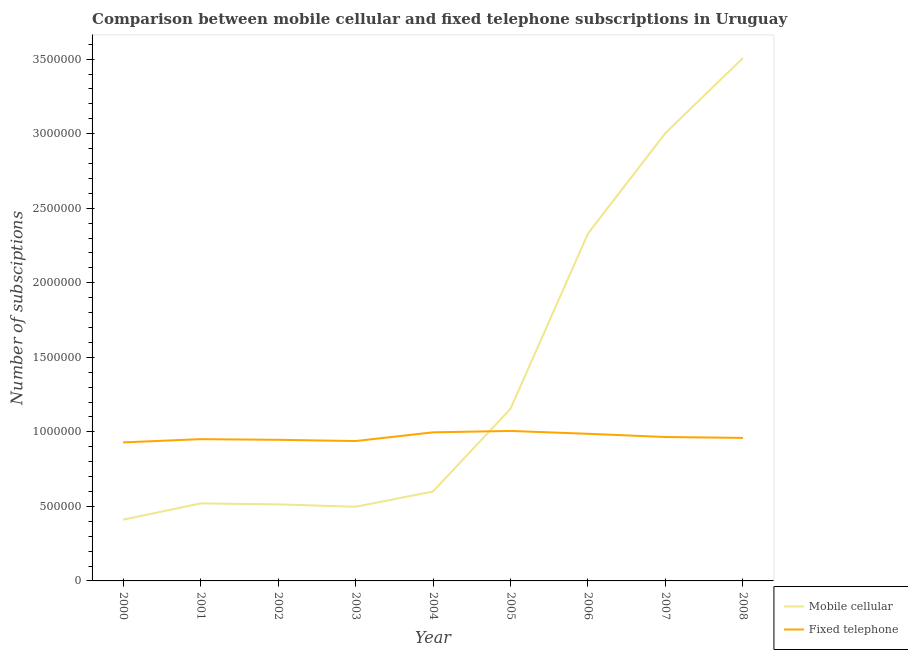What is the number of mobile cellular subscriptions in 2003?
Your answer should be compact. 4.98e+05. Across all years, what is the maximum number of mobile cellular subscriptions?
Offer a very short reply. 3.51e+06. Across all years, what is the minimum number of mobile cellular subscriptions?
Your answer should be very brief. 4.11e+05. In which year was the number of fixed telephone subscriptions minimum?
Your answer should be very brief. 2000. What is the total number of mobile cellular subscriptions in the graph?
Give a very brief answer. 1.25e+07. What is the difference between the number of mobile cellular subscriptions in 2004 and that in 2007?
Your response must be concise. -2.40e+06. What is the difference between the number of fixed telephone subscriptions in 2007 and the number of mobile cellular subscriptions in 2006?
Provide a short and direct response. -1.36e+06. What is the average number of mobile cellular subscriptions per year?
Give a very brief answer. 1.39e+06. In the year 2000, what is the difference between the number of fixed telephone subscriptions and number of mobile cellular subscriptions?
Your answer should be compact. 5.18e+05. What is the ratio of the number of fixed telephone subscriptions in 2005 to that in 2007?
Make the answer very short. 1.04. Is the number of fixed telephone subscriptions in 2000 less than that in 2006?
Ensure brevity in your answer.  Yes. Is the difference between the number of mobile cellular subscriptions in 2003 and 2008 greater than the difference between the number of fixed telephone subscriptions in 2003 and 2008?
Offer a very short reply. No. What is the difference between the highest and the second highest number of fixed telephone subscriptions?
Ensure brevity in your answer.  9300. What is the difference between the highest and the lowest number of mobile cellular subscriptions?
Your answer should be compact. 3.10e+06. Is the sum of the number of fixed telephone subscriptions in 2001 and 2008 greater than the maximum number of mobile cellular subscriptions across all years?
Make the answer very short. No. Is the number of mobile cellular subscriptions strictly greater than the number of fixed telephone subscriptions over the years?
Offer a terse response. No. Does the graph contain any zero values?
Keep it short and to the point. No. Where does the legend appear in the graph?
Your answer should be very brief. Bottom right. How many legend labels are there?
Your answer should be very brief. 2. How are the legend labels stacked?
Give a very brief answer. Vertical. What is the title of the graph?
Offer a terse response. Comparison between mobile cellular and fixed telephone subscriptions in Uruguay. What is the label or title of the X-axis?
Make the answer very short. Year. What is the label or title of the Y-axis?
Keep it short and to the point. Number of subsciptions. What is the Number of subsciptions in Mobile cellular in 2000?
Offer a terse response. 4.11e+05. What is the Number of subsciptions in Fixed telephone in 2000?
Your answer should be very brief. 9.29e+05. What is the Number of subsciptions of Mobile cellular in 2001?
Provide a short and direct response. 5.20e+05. What is the Number of subsciptions of Fixed telephone in 2001?
Your response must be concise. 9.51e+05. What is the Number of subsciptions in Mobile cellular in 2002?
Give a very brief answer. 5.14e+05. What is the Number of subsciptions in Fixed telephone in 2002?
Give a very brief answer. 9.47e+05. What is the Number of subsciptions of Mobile cellular in 2003?
Give a very brief answer. 4.98e+05. What is the Number of subsciptions of Fixed telephone in 2003?
Offer a very short reply. 9.38e+05. What is the Number of subsciptions of Mobile cellular in 2004?
Your response must be concise. 6.00e+05. What is the Number of subsciptions of Fixed telephone in 2004?
Make the answer very short. 9.97e+05. What is the Number of subsciptions in Mobile cellular in 2005?
Provide a succinct answer. 1.15e+06. What is the Number of subsciptions in Fixed telephone in 2005?
Your answer should be very brief. 1.01e+06. What is the Number of subsciptions of Mobile cellular in 2006?
Keep it short and to the point. 2.33e+06. What is the Number of subsciptions in Fixed telephone in 2006?
Offer a terse response. 9.87e+05. What is the Number of subsciptions of Mobile cellular in 2007?
Ensure brevity in your answer.  3.00e+06. What is the Number of subsciptions of Fixed telephone in 2007?
Provide a succinct answer. 9.65e+05. What is the Number of subsciptions in Mobile cellular in 2008?
Ensure brevity in your answer.  3.51e+06. What is the Number of subsciptions in Fixed telephone in 2008?
Make the answer very short. 9.59e+05. Across all years, what is the maximum Number of subsciptions of Mobile cellular?
Keep it short and to the point. 3.51e+06. Across all years, what is the maximum Number of subsciptions in Fixed telephone?
Your answer should be compact. 1.01e+06. Across all years, what is the minimum Number of subsciptions of Mobile cellular?
Keep it short and to the point. 4.11e+05. Across all years, what is the minimum Number of subsciptions of Fixed telephone?
Provide a succinct answer. 9.29e+05. What is the total Number of subsciptions of Mobile cellular in the graph?
Make the answer very short. 1.25e+07. What is the total Number of subsciptions in Fixed telephone in the graph?
Provide a succinct answer. 8.68e+06. What is the difference between the Number of subsciptions of Mobile cellular in 2000 and that in 2001?
Make the answer very short. -1.09e+05. What is the difference between the Number of subsciptions of Fixed telephone in 2000 and that in 2001?
Ensure brevity in your answer.  -2.17e+04. What is the difference between the Number of subsciptions of Mobile cellular in 2000 and that in 2002?
Provide a succinct answer. -1.03e+05. What is the difference between the Number of subsciptions of Fixed telephone in 2000 and that in 2002?
Provide a short and direct response. -1.74e+04. What is the difference between the Number of subsciptions of Mobile cellular in 2000 and that in 2003?
Offer a terse response. -8.67e+04. What is the difference between the Number of subsciptions of Fixed telephone in 2000 and that in 2003?
Your response must be concise. -9045. What is the difference between the Number of subsciptions of Mobile cellular in 2000 and that in 2004?
Ensure brevity in your answer.  -1.89e+05. What is the difference between the Number of subsciptions of Fixed telephone in 2000 and that in 2004?
Provide a short and direct response. -6.76e+04. What is the difference between the Number of subsciptions in Mobile cellular in 2000 and that in 2005?
Make the answer very short. -7.44e+05. What is the difference between the Number of subsciptions of Fixed telephone in 2000 and that in 2005?
Give a very brief answer. -7.69e+04. What is the difference between the Number of subsciptions of Mobile cellular in 2000 and that in 2006?
Ensure brevity in your answer.  -1.92e+06. What is the difference between the Number of subsciptions of Fixed telephone in 2000 and that in 2006?
Your response must be concise. -5.77e+04. What is the difference between the Number of subsciptions in Mobile cellular in 2000 and that in 2007?
Provide a succinct answer. -2.59e+06. What is the difference between the Number of subsciptions in Fixed telephone in 2000 and that in 2007?
Offer a very short reply. -3.61e+04. What is the difference between the Number of subsciptions in Mobile cellular in 2000 and that in 2008?
Make the answer very short. -3.10e+06. What is the difference between the Number of subsciptions of Fixed telephone in 2000 and that in 2008?
Give a very brief answer. -3.01e+04. What is the difference between the Number of subsciptions of Mobile cellular in 2001 and that in 2002?
Provide a succinct answer. 6463. What is the difference between the Number of subsciptions of Fixed telephone in 2001 and that in 2002?
Give a very brief answer. 4333. What is the difference between the Number of subsciptions of Mobile cellular in 2001 and that in 2003?
Provide a short and direct response. 2.25e+04. What is the difference between the Number of subsciptions in Fixed telephone in 2001 and that in 2003?
Your answer should be compact. 1.27e+04. What is the difference between the Number of subsciptions of Mobile cellular in 2001 and that in 2004?
Ensure brevity in your answer.  -7.98e+04. What is the difference between the Number of subsciptions of Fixed telephone in 2001 and that in 2004?
Give a very brief answer. -4.58e+04. What is the difference between the Number of subsciptions in Mobile cellular in 2001 and that in 2005?
Provide a succinct answer. -6.35e+05. What is the difference between the Number of subsciptions in Fixed telephone in 2001 and that in 2005?
Offer a very short reply. -5.51e+04. What is the difference between the Number of subsciptions in Mobile cellular in 2001 and that in 2006?
Your answer should be compact. -1.81e+06. What is the difference between the Number of subsciptions in Fixed telephone in 2001 and that in 2006?
Your response must be concise. -3.60e+04. What is the difference between the Number of subsciptions in Mobile cellular in 2001 and that in 2007?
Keep it short and to the point. -2.48e+06. What is the difference between the Number of subsciptions of Fixed telephone in 2001 and that in 2007?
Keep it short and to the point. -1.44e+04. What is the difference between the Number of subsciptions in Mobile cellular in 2001 and that in 2008?
Give a very brief answer. -2.99e+06. What is the difference between the Number of subsciptions of Fixed telephone in 2001 and that in 2008?
Give a very brief answer. -8420. What is the difference between the Number of subsciptions in Mobile cellular in 2002 and that in 2003?
Make the answer very short. 1.60e+04. What is the difference between the Number of subsciptions in Fixed telephone in 2002 and that in 2003?
Offer a very short reply. 8347. What is the difference between the Number of subsciptions in Mobile cellular in 2002 and that in 2004?
Keep it short and to the point. -8.62e+04. What is the difference between the Number of subsciptions in Fixed telephone in 2002 and that in 2004?
Give a very brief answer. -5.02e+04. What is the difference between the Number of subsciptions in Mobile cellular in 2002 and that in 2005?
Offer a very short reply. -6.41e+05. What is the difference between the Number of subsciptions in Fixed telephone in 2002 and that in 2005?
Offer a very short reply. -5.95e+04. What is the difference between the Number of subsciptions in Mobile cellular in 2002 and that in 2006?
Keep it short and to the point. -1.82e+06. What is the difference between the Number of subsciptions of Fixed telephone in 2002 and that in 2006?
Provide a short and direct response. -4.03e+04. What is the difference between the Number of subsciptions of Mobile cellular in 2002 and that in 2007?
Your answer should be compact. -2.49e+06. What is the difference between the Number of subsciptions in Fixed telephone in 2002 and that in 2007?
Your answer should be compact. -1.87e+04. What is the difference between the Number of subsciptions of Mobile cellular in 2002 and that in 2008?
Offer a terse response. -2.99e+06. What is the difference between the Number of subsciptions of Fixed telephone in 2002 and that in 2008?
Your answer should be compact. -1.28e+04. What is the difference between the Number of subsciptions of Mobile cellular in 2003 and that in 2004?
Your response must be concise. -1.02e+05. What is the difference between the Number of subsciptions in Fixed telephone in 2003 and that in 2004?
Offer a terse response. -5.85e+04. What is the difference between the Number of subsciptions of Mobile cellular in 2003 and that in 2005?
Offer a very short reply. -6.57e+05. What is the difference between the Number of subsciptions in Fixed telephone in 2003 and that in 2005?
Keep it short and to the point. -6.78e+04. What is the difference between the Number of subsciptions in Mobile cellular in 2003 and that in 2006?
Your answer should be very brief. -1.83e+06. What is the difference between the Number of subsciptions of Fixed telephone in 2003 and that in 2006?
Give a very brief answer. -4.87e+04. What is the difference between the Number of subsciptions of Mobile cellular in 2003 and that in 2007?
Ensure brevity in your answer.  -2.51e+06. What is the difference between the Number of subsciptions of Fixed telephone in 2003 and that in 2007?
Provide a short and direct response. -2.70e+04. What is the difference between the Number of subsciptions in Mobile cellular in 2003 and that in 2008?
Your answer should be compact. -3.01e+06. What is the difference between the Number of subsciptions of Fixed telephone in 2003 and that in 2008?
Make the answer very short. -2.11e+04. What is the difference between the Number of subsciptions in Mobile cellular in 2004 and that in 2005?
Your answer should be very brief. -5.55e+05. What is the difference between the Number of subsciptions in Fixed telephone in 2004 and that in 2005?
Give a very brief answer. -9300. What is the difference between the Number of subsciptions in Mobile cellular in 2004 and that in 2006?
Offer a very short reply. -1.73e+06. What is the difference between the Number of subsciptions of Fixed telephone in 2004 and that in 2006?
Keep it short and to the point. 9834. What is the difference between the Number of subsciptions of Mobile cellular in 2004 and that in 2007?
Ensure brevity in your answer.  -2.40e+06. What is the difference between the Number of subsciptions of Fixed telephone in 2004 and that in 2007?
Provide a short and direct response. 3.15e+04. What is the difference between the Number of subsciptions of Mobile cellular in 2004 and that in 2008?
Provide a succinct answer. -2.91e+06. What is the difference between the Number of subsciptions of Fixed telephone in 2004 and that in 2008?
Provide a short and direct response. 3.74e+04. What is the difference between the Number of subsciptions of Mobile cellular in 2005 and that in 2006?
Offer a very short reply. -1.18e+06. What is the difference between the Number of subsciptions of Fixed telephone in 2005 and that in 2006?
Your answer should be very brief. 1.91e+04. What is the difference between the Number of subsciptions in Mobile cellular in 2005 and that in 2007?
Make the answer very short. -1.85e+06. What is the difference between the Number of subsciptions in Fixed telephone in 2005 and that in 2007?
Make the answer very short. 4.08e+04. What is the difference between the Number of subsciptions in Mobile cellular in 2005 and that in 2008?
Keep it short and to the point. -2.35e+06. What is the difference between the Number of subsciptions of Fixed telephone in 2005 and that in 2008?
Provide a succinct answer. 4.67e+04. What is the difference between the Number of subsciptions of Mobile cellular in 2006 and that in 2007?
Give a very brief answer. -6.74e+05. What is the difference between the Number of subsciptions of Fixed telephone in 2006 and that in 2007?
Give a very brief answer. 2.17e+04. What is the difference between the Number of subsciptions of Mobile cellular in 2006 and that in 2008?
Provide a short and direct response. -1.18e+06. What is the difference between the Number of subsciptions in Fixed telephone in 2006 and that in 2008?
Keep it short and to the point. 2.76e+04. What is the difference between the Number of subsciptions in Mobile cellular in 2007 and that in 2008?
Your answer should be very brief. -5.03e+05. What is the difference between the Number of subsciptions in Fixed telephone in 2007 and that in 2008?
Offer a very short reply. 5930. What is the difference between the Number of subsciptions in Mobile cellular in 2000 and the Number of subsciptions in Fixed telephone in 2001?
Offer a terse response. -5.40e+05. What is the difference between the Number of subsciptions in Mobile cellular in 2000 and the Number of subsciptions in Fixed telephone in 2002?
Provide a succinct answer. -5.36e+05. What is the difference between the Number of subsciptions in Mobile cellular in 2000 and the Number of subsciptions in Fixed telephone in 2003?
Provide a short and direct response. -5.27e+05. What is the difference between the Number of subsciptions in Mobile cellular in 2000 and the Number of subsciptions in Fixed telephone in 2004?
Your response must be concise. -5.86e+05. What is the difference between the Number of subsciptions of Mobile cellular in 2000 and the Number of subsciptions of Fixed telephone in 2005?
Ensure brevity in your answer.  -5.95e+05. What is the difference between the Number of subsciptions of Mobile cellular in 2000 and the Number of subsciptions of Fixed telephone in 2006?
Keep it short and to the point. -5.76e+05. What is the difference between the Number of subsciptions in Mobile cellular in 2000 and the Number of subsciptions in Fixed telephone in 2007?
Offer a terse response. -5.54e+05. What is the difference between the Number of subsciptions of Mobile cellular in 2000 and the Number of subsciptions of Fixed telephone in 2008?
Ensure brevity in your answer.  -5.48e+05. What is the difference between the Number of subsciptions in Mobile cellular in 2001 and the Number of subsciptions in Fixed telephone in 2002?
Offer a very short reply. -4.27e+05. What is the difference between the Number of subsciptions of Mobile cellular in 2001 and the Number of subsciptions of Fixed telephone in 2003?
Offer a very short reply. -4.18e+05. What is the difference between the Number of subsciptions in Mobile cellular in 2001 and the Number of subsciptions in Fixed telephone in 2004?
Your response must be concise. -4.77e+05. What is the difference between the Number of subsciptions of Mobile cellular in 2001 and the Number of subsciptions of Fixed telephone in 2005?
Your answer should be very brief. -4.86e+05. What is the difference between the Number of subsciptions in Mobile cellular in 2001 and the Number of subsciptions in Fixed telephone in 2006?
Make the answer very short. -4.67e+05. What is the difference between the Number of subsciptions in Mobile cellular in 2001 and the Number of subsciptions in Fixed telephone in 2007?
Your response must be concise. -4.45e+05. What is the difference between the Number of subsciptions of Mobile cellular in 2001 and the Number of subsciptions of Fixed telephone in 2008?
Keep it short and to the point. -4.39e+05. What is the difference between the Number of subsciptions in Mobile cellular in 2002 and the Number of subsciptions in Fixed telephone in 2003?
Provide a short and direct response. -4.25e+05. What is the difference between the Number of subsciptions in Mobile cellular in 2002 and the Number of subsciptions in Fixed telephone in 2004?
Your answer should be compact. -4.83e+05. What is the difference between the Number of subsciptions in Mobile cellular in 2002 and the Number of subsciptions in Fixed telephone in 2005?
Give a very brief answer. -4.92e+05. What is the difference between the Number of subsciptions in Mobile cellular in 2002 and the Number of subsciptions in Fixed telephone in 2006?
Keep it short and to the point. -4.73e+05. What is the difference between the Number of subsciptions of Mobile cellular in 2002 and the Number of subsciptions of Fixed telephone in 2007?
Your response must be concise. -4.52e+05. What is the difference between the Number of subsciptions in Mobile cellular in 2002 and the Number of subsciptions in Fixed telephone in 2008?
Provide a succinct answer. -4.46e+05. What is the difference between the Number of subsciptions in Mobile cellular in 2003 and the Number of subsciptions in Fixed telephone in 2004?
Make the answer very short. -4.99e+05. What is the difference between the Number of subsciptions in Mobile cellular in 2003 and the Number of subsciptions in Fixed telephone in 2005?
Offer a terse response. -5.08e+05. What is the difference between the Number of subsciptions in Mobile cellular in 2003 and the Number of subsciptions in Fixed telephone in 2006?
Offer a very short reply. -4.89e+05. What is the difference between the Number of subsciptions in Mobile cellular in 2003 and the Number of subsciptions in Fixed telephone in 2007?
Provide a succinct answer. -4.68e+05. What is the difference between the Number of subsciptions in Mobile cellular in 2003 and the Number of subsciptions in Fixed telephone in 2008?
Keep it short and to the point. -4.62e+05. What is the difference between the Number of subsciptions of Mobile cellular in 2004 and the Number of subsciptions of Fixed telephone in 2005?
Your response must be concise. -4.06e+05. What is the difference between the Number of subsciptions of Mobile cellular in 2004 and the Number of subsciptions of Fixed telephone in 2006?
Your answer should be very brief. -3.87e+05. What is the difference between the Number of subsciptions of Mobile cellular in 2004 and the Number of subsciptions of Fixed telephone in 2007?
Ensure brevity in your answer.  -3.65e+05. What is the difference between the Number of subsciptions in Mobile cellular in 2004 and the Number of subsciptions in Fixed telephone in 2008?
Make the answer very short. -3.60e+05. What is the difference between the Number of subsciptions in Mobile cellular in 2005 and the Number of subsciptions in Fixed telephone in 2006?
Provide a short and direct response. 1.68e+05. What is the difference between the Number of subsciptions of Mobile cellular in 2005 and the Number of subsciptions of Fixed telephone in 2007?
Your answer should be compact. 1.90e+05. What is the difference between the Number of subsciptions in Mobile cellular in 2005 and the Number of subsciptions in Fixed telephone in 2008?
Your answer should be compact. 1.96e+05. What is the difference between the Number of subsciptions of Mobile cellular in 2006 and the Number of subsciptions of Fixed telephone in 2007?
Your answer should be compact. 1.36e+06. What is the difference between the Number of subsciptions in Mobile cellular in 2006 and the Number of subsciptions in Fixed telephone in 2008?
Make the answer very short. 1.37e+06. What is the difference between the Number of subsciptions of Mobile cellular in 2007 and the Number of subsciptions of Fixed telephone in 2008?
Offer a very short reply. 2.05e+06. What is the average Number of subsciptions of Mobile cellular per year?
Make the answer very short. 1.39e+06. What is the average Number of subsciptions of Fixed telephone per year?
Your answer should be very brief. 9.64e+05. In the year 2000, what is the difference between the Number of subsciptions in Mobile cellular and Number of subsciptions in Fixed telephone?
Offer a very short reply. -5.18e+05. In the year 2001, what is the difference between the Number of subsciptions of Mobile cellular and Number of subsciptions of Fixed telephone?
Offer a terse response. -4.31e+05. In the year 2002, what is the difference between the Number of subsciptions in Mobile cellular and Number of subsciptions in Fixed telephone?
Provide a short and direct response. -4.33e+05. In the year 2003, what is the difference between the Number of subsciptions of Mobile cellular and Number of subsciptions of Fixed telephone?
Offer a terse response. -4.41e+05. In the year 2004, what is the difference between the Number of subsciptions in Mobile cellular and Number of subsciptions in Fixed telephone?
Offer a terse response. -3.97e+05. In the year 2005, what is the difference between the Number of subsciptions in Mobile cellular and Number of subsciptions in Fixed telephone?
Make the answer very short. 1.49e+05. In the year 2006, what is the difference between the Number of subsciptions in Mobile cellular and Number of subsciptions in Fixed telephone?
Offer a terse response. 1.34e+06. In the year 2007, what is the difference between the Number of subsciptions of Mobile cellular and Number of subsciptions of Fixed telephone?
Offer a terse response. 2.04e+06. In the year 2008, what is the difference between the Number of subsciptions of Mobile cellular and Number of subsciptions of Fixed telephone?
Offer a very short reply. 2.55e+06. What is the ratio of the Number of subsciptions in Mobile cellular in 2000 to that in 2001?
Your answer should be compact. 0.79. What is the ratio of the Number of subsciptions of Fixed telephone in 2000 to that in 2001?
Your answer should be compact. 0.98. What is the ratio of the Number of subsciptions of Mobile cellular in 2000 to that in 2002?
Provide a succinct answer. 0.8. What is the ratio of the Number of subsciptions in Fixed telephone in 2000 to that in 2002?
Your answer should be very brief. 0.98. What is the ratio of the Number of subsciptions in Mobile cellular in 2000 to that in 2003?
Your answer should be very brief. 0.83. What is the ratio of the Number of subsciptions in Mobile cellular in 2000 to that in 2004?
Your answer should be very brief. 0.68. What is the ratio of the Number of subsciptions of Fixed telephone in 2000 to that in 2004?
Provide a succinct answer. 0.93. What is the ratio of the Number of subsciptions of Mobile cellular in 2000 to that in 2005?
Your answer should be compact. 0.36. What is the ratio of the Number of subsciptions in Fixed telephone in 2000 to that in 2005?
Your answer should be very brief. 0.92. What is the ratio of the Number of subsciptions in Mobile cellular in 2000 to that in 2006?
Your answer should be compact. 0.18. What is the ratio of the Number of subsciptions in Fixed telephone in 2000 to that in 2006?
Your answer should be very brief. 0.94. What is the ratio of the Number of subsciptions of Mobile cellular in 2000 to that in 2007?
Your answer should be very brief. 0.14. What is the ratio of the Number of subsciptions in Fixed telephone in 2000 to that in 2007?
Your answer should be compact. 0.96. What is the ratio of the Number of subsciptions of Mobile cellular in 2000 to that in 2008?
Make the answer very short. 0.12. What is the ratio of the Number of subsciptions in Fixed telephone in 2000 to that in 2008?
Ensure brevity in your answer.  0.97. What is the ratio of the Number of subsciptions of Mobile cellular in 2001 to that in 2002?
Offer a very short reply. 1.01. What is the ratio of the Number of subsciptions of Fixed telephone in 2001 to that in 2002?
Provide a succinct answer. 1. What is the ratio of the Number of subsciptions in Mobile cellular in 2001 to that in 2003?
Your answer should be very brief. 1.05. What is the ratio of the Number of subsciptions in Fixed telephone in 2001 to that in 2003?
Offer a very short reply. 1.01. What is the ratio of the Number of subsciptions in Mobile cellular in 2001 to that in 2004?
Your response must be concise. 0.87. What is the ratio of the Number of subsciptions of Fixed telephone in 2001 to that in 2004?
Offer a terse response. 0.95. What is the ratio of the Number of subsciptions in Mobile cellular in 2001 to that in 2005?
Ensure brevity in your answer.  0.45. What is the ratio of the Number of subsciptions of Fixed telephone in 2001 to that in 2005?
Offer a terse response. 0.95. What is the ratio of the Number of subsciptions in Mobile cellular in 2001 to that in 2006?
Your answer should be compact. 0.22. What is the ratio of the Number of subsciptions of Fixed telephone in 2001 to that in 2006?
Your response must be concise. 0.96. What is the ratio of the Number of subsciptions of Mobile cellular in 2001 to that in 2007?
Your answer should be very brief. 0.17. What is the ratio of the Number of subsciptions of Fixed telephone in 2001 to that in 2007?
Offer a terse response. 0.99. What is the ratio of the Number of subsciptions of Mobile cellular in 2001 to that in 2008?
Ensure brevity in your answer.  0.15. What is the ratio of the Number of subsciptions of Fixed telephone in 2001 to that in 2008?
Your answer should be very brief. 0.99. What is the ratio of the Number of subsciptions in Mobile cellular in 2002 to that in 2003?
Provide a succinct answer. 1.03. What is the ratio of the Number of subsciptions in Fixed telephone in 2002 to that in 2003?
Provide a succinct answer. 1.01. What is the ratio of the Number of subsciptions of Mobile cellular in 2002 to that in 2004?
Keep it short and to the point. 0.86. What is the ratio of the Number of subsciptions of Fixed telephone in 2002 to that in 2004?
Offer a terse response. 0.95. What is the ratio of the Number of subsciptions of Mobile cellular in 2002 to that in 2005?
Your response must be concise. 0.44. What is the ratio of the Number of subsciptions of Fixed telephone in 2002 to that in 2005?
Your answer should be compact. 0.94. What is the ratio of the Number of subsciptions of Mobile cellular in 2002 to that in 2006?
Keep it short and to the point. 0.22. What is the ratio of the Number of subsciptions in Fixed telephone in 2002 to that in 2006?
Your response must be concise. 0.96. What is the ratio of the Number of subsciptions in Mobile cellular in 2002 to that in 2007?
Provide a succinct answer. 0.17. What is the ratio of the Number of subsciptions of Fixed telephone in 2002 to that in 2007?
Provide a succinct answer. 0.98. What is the ratio of the Number of subsciptions of Mobile cellular in 2002 to that in 2008?
Your response must be concise. 0.15. What is the ratio of the Number of subsciptions in Fixed telephone in 2002 to that in 2008?
Offer a very short reply. 0.99. What is the ratio of the Number of subsciptions in Mobile cellular in 2003 to that in 2004?
Make the answer very short. 0.83. What is the ratio of the Number of subsciptions of Fixed telephone in 2003 to that in 2004?
Offer a very short reply. 0.94. What is the ratio of the Number of subsciptions of Mobile cellular in 2003 to that in 2005?
Offer a very short reply. 0.43. What is the ratio of the Number of subsciptions of Fixed telephone in 2003 to that in 2005?
Ensure brevity in your answer.  0.93. What is the ratio of the Number of subsciptions of Mobile cellular in 2003 to that in 2006?
Your answer should be compact. 0.21. What is the ratio of the Number of subsciptions in Fixed telephone in 2003 to that in 2006?
Keep it short and to the point. 0.95. What is the ratio of the Number of subsciptions in Mobile cellular in 2003 to that in 2007?
Ensure brevity in your answer.  0.17. What is the ratio of the Number of subsciptions in Fixed telephone in 2003 to that in 2007?
Keep it short and to the point. 0.97. What is the ratio of the Number of subsciptions in Mobile cellular in 2003 to that in 2008?
Make the answer very short. 0.14. What is the ratio of the Number of subsciptions in Fixed telephone in 2003 to that in 2008?
Ensure brevity in your answer.  0.98. What is the ratio of the Number of subsciptions of Mobile cellular in 2004 to that in 2005?
Provide a short and direct response. 0.52. What is the ratio of the Number of subsciptions of Fixed telephone in 2004 to that in 2005?
Give a very brief answer. 0.99. What is the ratio of the Number of subsciptions in Mobile cellular in 2004 to that in 2006?
Your answer should be very brief. 0.26. What is the ratio of the Number of subsciptions in Fixed telephone in 2004 to that in 2006?
Give a very brief answer. 1.01. What is the ratio of the Number of subsciptions of Mobile cellular in 2004 to that in 2007?
Keep it short and to the point. 0.2. What is the ratio of the Number of subsciptions of Fixed telephone in 2004 to that in 2007?
Provide a short and direct response. 1.03. What is the ratio of the Number of subsciptions of Mobile cellular in 2004 to that in 2008?
Keep it short and to the point. 0.17. What is the ratio of the Number of subsciptions of Fixed telephone in 2004 to that in 2008?
Your answer should be very brief. 1.04. What is the ratio of the Number of subsciptions in Mobile cellular in 2005 to that in 2006?
Your response must be concise. 0.5. What is the ratio of the Number of subsciptions of Fixed telephone in 2005 to that in 2006?
Keep it short and to the point. 1.02. What is the ratio of the Number of subsciptions of Mobile cellular in 2005 to that in 2007?
Provide a short and direct response. 0.38. What is the ratio of the Number of subsciptions of Fixed telephone in 2005 to that in 2007?
Offer a terse response. 1.04. What is the ratio of the Number of subsciptions of Mobile cellular in 2005 to that in 2008?
Offer a very short reply. 0.33. What is the ratio of the Number of subsciptions of Fixed telephone in 2005 to that in 2008?
Give a very brief answer. 1.05. What is the ratio of the Number of subsciptions of Mobile cellular in 2006 to that in 2007?
Provide a short and direct response. 0.78. What is the ratio of the Number of subsciptions of Fixed telephone in 2006 to that in 2007?
Your answer should be very brief. 1.02. What is the ratio of the Number of subsciptions in Mobile cellular in 2006 to that in 2008?
Ensure brevity in your answer.  0.66. What is the ratio of the Number of subsciptions in Fixed telephone in 2006 to that in 2008?
Give a very brief answer. 1.03. What is the ratio of the Number of subsciptions of Mobile cellular in 2007 to that in 2008?
Your response must be concise. 0.86. What is the ratio of the Number of subsciptions in Fixed telephone in 2007 to that in 2008?
Keep it short and to the point. 1.01. What is the difference between the highest and the second highest Number of subsciptions in Mobile cellular?
Give a very brief answer. 5.03e+05. What is the difference between the highest and the second highest Number of subsciptions of Fixed telephone?
Your response must be concise. 9300. What is the difference between the highest and the lowest Number of subsciptions in Mobile cellular?
Offer a very short reply. 3.10e+06. What is the difference between the highest and the lowest Number of subsciptions of Fixed telephone?
Make the answer very short. 7.69e+04. 